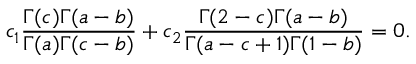<formula> <loc_0><loc_0><loc_500><loc_500>c _ { 1 } \frac { \Gamma ( c ) \Gamma ( a - b ) } { \Gamma ( a ) \Gamma ( c - b ) } + c _ { 2 } \frac { \Gamma ( 2 - c ) \Gamma ( a - b ) } { \Gamma ( a - c + 1 ) \Gamma ( 1 - b ) } = 0 .</formula> 